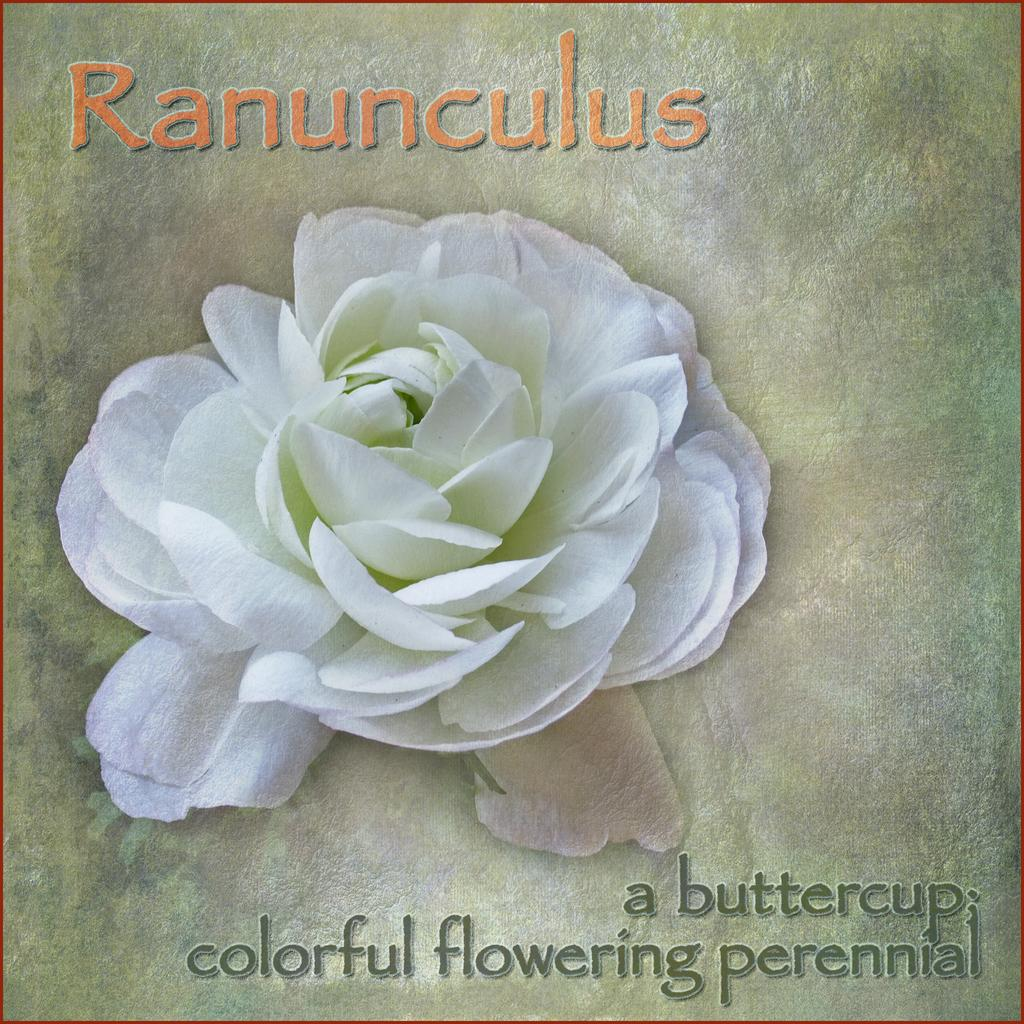What is the main subject of the poster in the image? The poster features a white flower. What else can be seen on the poster besides the flower? There is text or matter written on the poster. What color is the card in the middle of the image? There is no card present in the image. What type of shirt is the person wearing in the image? There is no person or shirt visible in the image; it only features a poster with a white flower and text. 